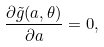Convert formula to latex. <formula><loc_0><loc_0><loc_500><loc_500>\frac { \partial \tilde { g } ( a , \theta ) } { \partial a } = 0 ,</formula> 